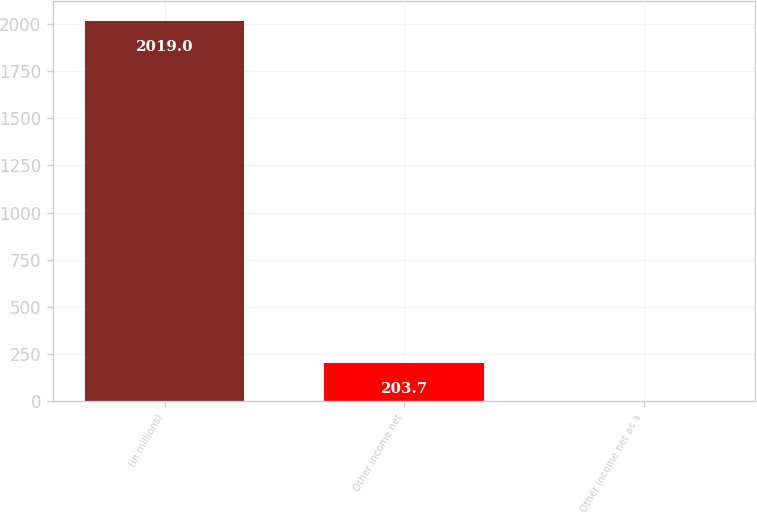<chart> <loc_0><loc_0><loc_500><loc_500><bar_chart><fcel>(in millions)<fcel>Other income net<fcel>Other income net as a<nl><fcel>2019<fcel>203.7<fcel>2<nl></chart> 